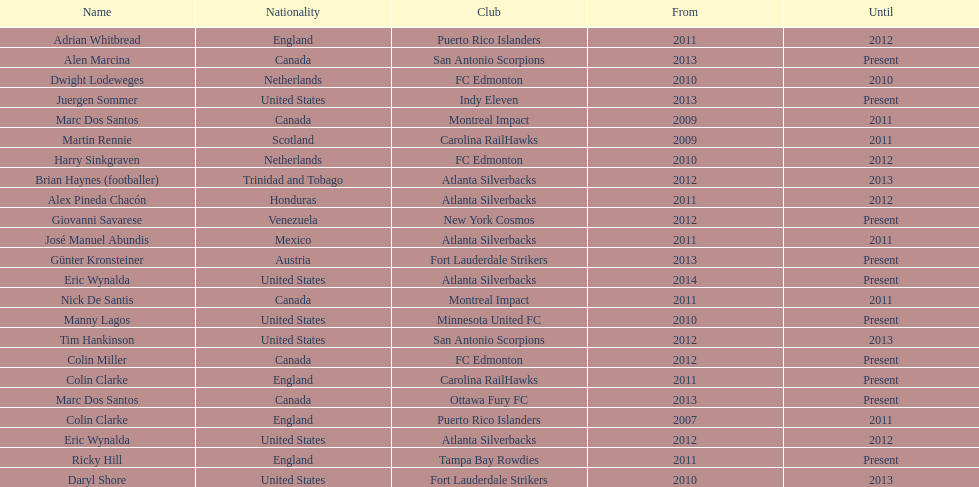How many coaches have coached from america? 6. 